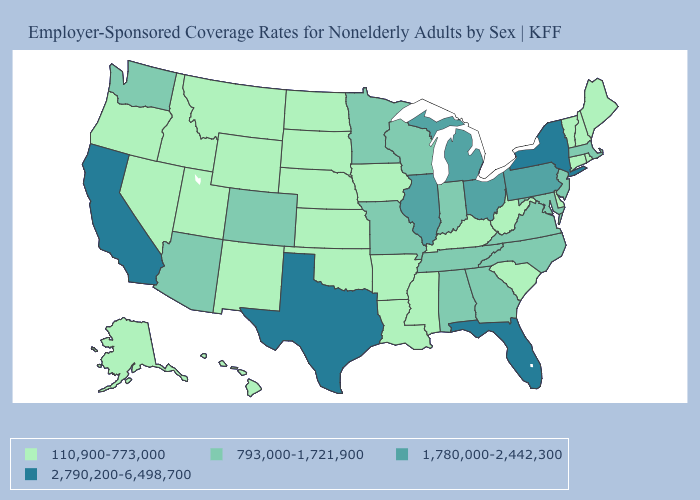Is the legend a continuous bar?
Give a very brief answer. No. Does Utah have a lower value than California?
Answer briefly. Yes. Name the states that have a value in the range 793,000-1,721,900?
Keep it brief. Alabama, Arizona, Colorado, Georgia, Indiana, Maryland, Massachusetts, Minnesota, Missouri, New Jersey, North Carolina, Tennessee, Virginia, Washington, Wisconsin. How many symbols are there in the legend?
Keep it brief. 4. What is the value of Delaware?
Write a very short answer. 110,900-773,000. Name the states that have a value in the range 2,790,200-6,498,700?
Concise answer only. California, Florida, New York, Texas. Name the states that have a value in the range 793,000-1,721,900?
Write a very short answer. Alabama, Arizona, Colorado, Georgia, Indiana, Maryland, Massachusetts, Minnesota, Missouri, New Jersey, North Carolina, Tennessee, Virginia, Washington, Wisconsin. Does Mississippi have the lowest value in the USA?
Concise answer only. Yes. Does Connecticut have the highest value in the USA?
Keep it brief. No. What is the lowest value in the West?
Answer briefly. 110,900-773,000. Does Colorado have the lowest value in the USA?
Be succinct. No. What is the value of Nevada?
Quick response, please. 110,900-773,000. What is the highest value in the USA?
Answer briefly. 2,790,200-6,498,700. What is the lowest value in the USA?
Write a very short answer. 110,900-773,000. What is the lowest value in the USA?
Write a very short answer. 110,900-773,000. 